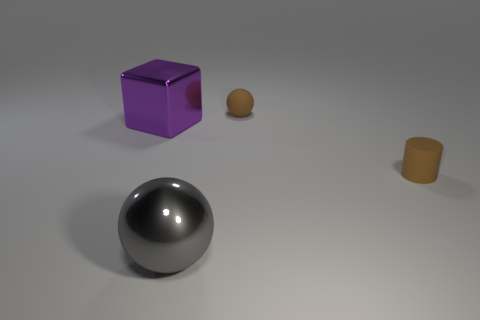How many brown spheres are the same material as the brown cylinder?
Offer a very short reply. 1. What is the shape of the thing that is the same color as the tiny rubber ball?
Give a very brief answer. Cylinder. There is a block that is on the left side of the small object that is behind the large purple metallic block; what size is it?
Your answer should be very brief. Large. There is a brown thing that is right of the rubber ball; is it the same shape as the brown object that is behind the tiny matte cylinder?
Your answer should be very brief. No. Is the number of brown rubber cylinders that are to the right of the rubber cylinder the same as the number of tiny purple matte blocks?
Provide a succinct answer. Yes. There is another small object that is the same shape as the gray object; what is its color?
Provide a succinct answer. Brown. Are the cube that is in front of the small sphere and the brown sphere made of the same material?
Your answer should be very brief. No. How many big objects are either purple shiny cubes or yellow metal things?
Provide a succinct answer. 1. What size is the gray metal sphere?
Offer a very short reply. Large. Do the purple object and the metal thing that is on the right side of the large cube have the same size?
Make the answer very short. Yes. 